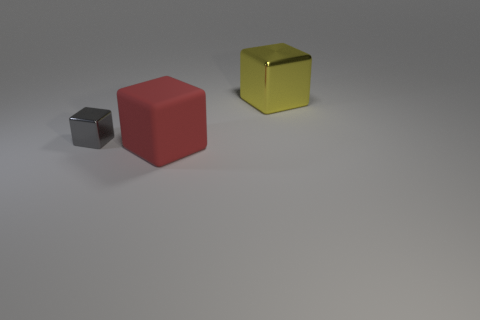The thing that is the same size as the yellow cube is what shape?
Ensure brevity in your answer.  Cube. There is a tiny gray thing that is the same shape as the red object; what is it made of?
Your response must be concise. Metal. What number of yellow metal blocks are the same size as the red thing?
Ensure brevity in your answer.  1. There is a tiny gray shiny object; what shape is it?
Keep it short and to the point. Cube. There is a block that is both in front of the yellow metal cube and to the right of the gray shiny block; what is its size?
Provide a short and direct response. Large. What is the material of the big object in front of the small gray object?
Keep it short and to the point. Rubber. Is the color of the large metal object the same as the shiny thing to the left of the red matte thing?
Your answer should be compact. No. How many things are either large blocks in front of the yellow shiny object or cubes that are behind the gray block?
Provide a short and direct response. 2. What color is the object that is both in front of the big yellow shiny block and behind the rubber cube?
Offer a terse response. Gray. Are there more yellow cubes than tiny red objects?
Keep it short and to the point. Yes. 